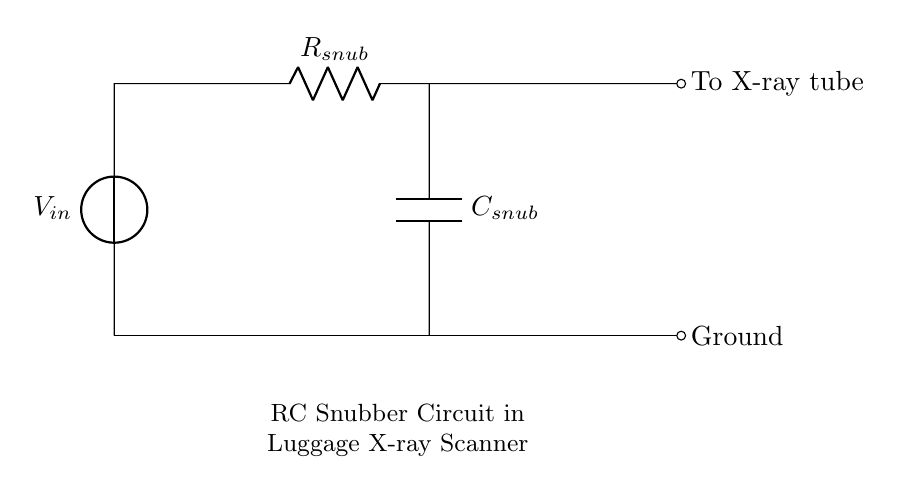What components are present in the circuit? The components in the circuit are a voltage source, a resistor, and a capacitor. These can be identified directly from the diagram: the voltage source provides input voltage, the resistor is labeled as R snub, and the capacitor is labeled as C snub.
Answer: voltage source, resistor, capacitor What does the resistor do in this RC snubber circuit? The resistor limits the current flow and helps in dissipating energy, smoothing out voltage spikes. In snubber circuits, it plays a crucial role in protecting sensitive components by controlling the rate of charge and discharge of the capacitor.
Answer: limits current What is the function of the capacitor in this circuit? The capacitor stores and releases electrical energy, helping to absorb voltage spikes and reduce electrical noise. In an RC snubber, the capacitor's charge and discharge characteristics help to stabilize the voltage across the X-ray tube.
Answer: absorbs voltage spikes Where is the output of the circuit directed to? The output of the circuit is directed to the X-ray tube, which is indicated in the diagram with the label "To X-ray tube." This output is essential for the functioning of the luggage X-ray scanner.
Answer: To X-ray tube How does the RC time constant affect the circuit's performance? The RC time constant, defined as the product of resistance and capacitance, determines how quickly the circuit responds to changes in voltage. A larger time constant results in slower charging/discharging of the capacitor, affecting the circuit's ability to filter voltage spikes effectively.
Answer: affects response speed What happens to the voltage across the capacitor during operation? The voltage across the capacitor rises as it charges during voltage spikes and drops as it discharges when the spikes subside. This behavior is essential to stabilize the overall voltage in the circuit, mitigating potential damage to sensitive components.
Answer: rises and drops 